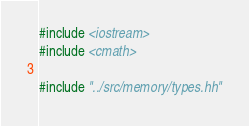Convert code to text. <code><loc_0><loc_0><loc_500><loc_500><_Cuda_>#include <iostream>
#include <cmath>

#include "../src/memory/types.hh"</code> 